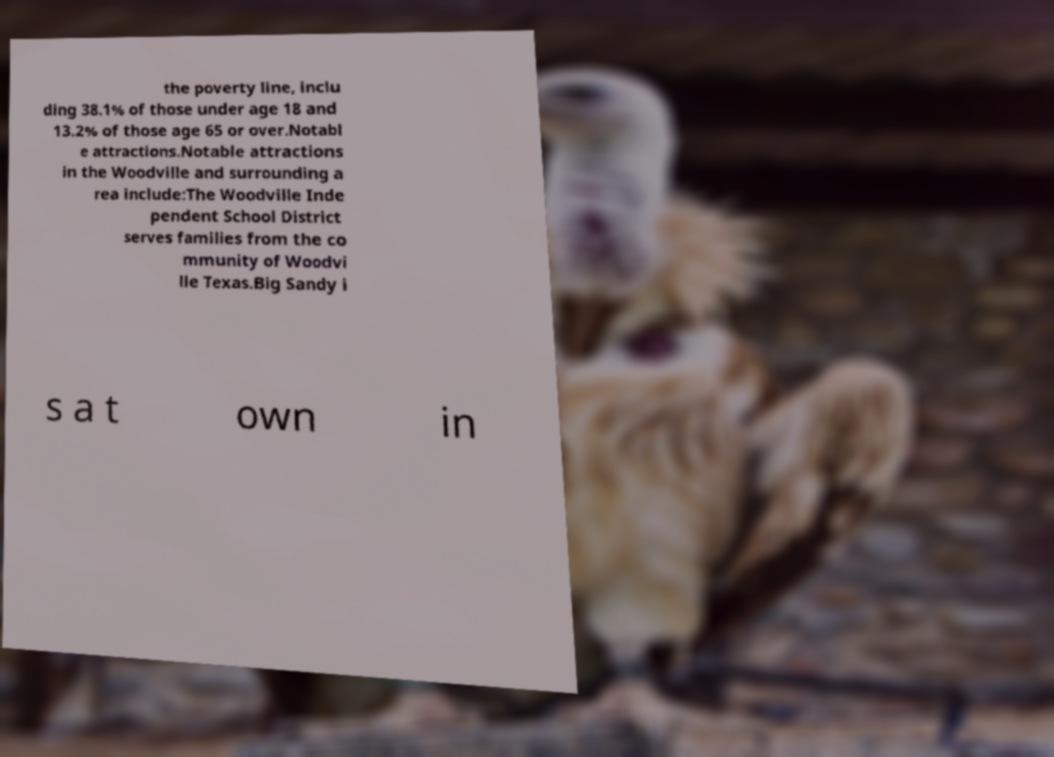There's text embedded in this image that I need extracted. Can you transcribe it verbatim? the poverty line, inclu ding 38.1% of those under age 18 and 13.2% of those age 65 or over.Notabl e attractions.Notable attractions in the Woodville and surrounding a rea include:The Woodville Inde pendent School District serves families from the co mmunity of Woodvi lle Texas.Big Sandy i s a t own in 